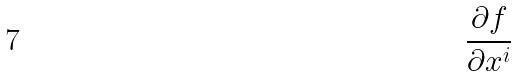Convert formula to latex. <formula><loc_0><loc_0><loc_500><loc_500>\frac { \partial f } { \partial x ^ { i } }</formula> 